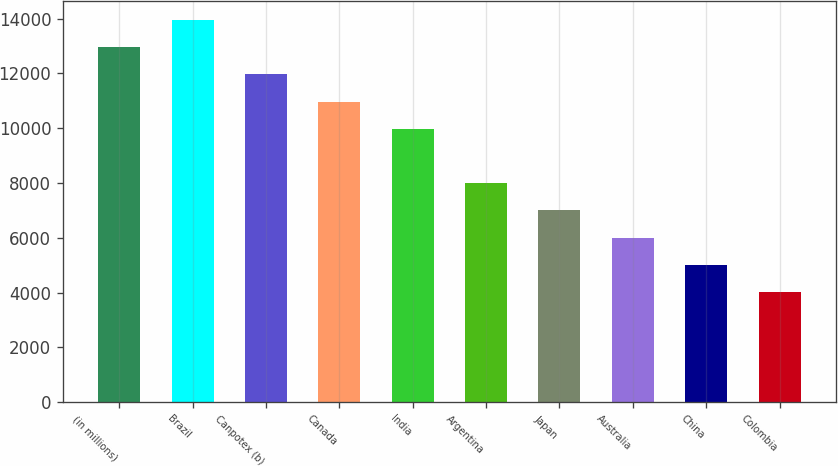Convert chart to OTSL. <chart><loc_0><loc_0><loc_500><loc_500><bar_chart><fcel>(in millions)<fcel>Brazil<fcel>Canpotex (b)<fcel>Canada<fcel>India<fcel>Argentina<fcel>Japan<fcel>Australia<fcel>China<fcel>Colombia<nl><fcel>12949.3<fcel>13941<fcel>11957.5<fcel>10965.8<fcel>9974.1<fcel>7990.66<fcel>6998.94<fcel>6007.22<fcel>5015.5<fcel>4023.78<nl></chart> 